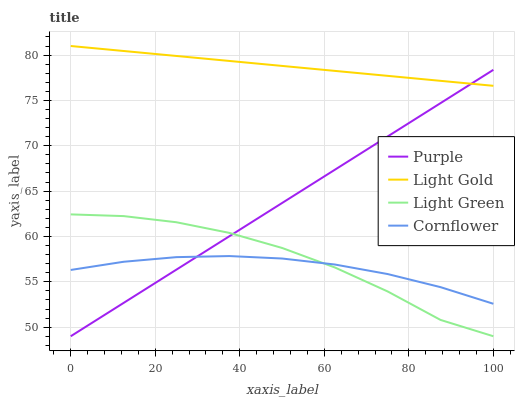Does Light Gold have the minimum area under the curve?
Answer yes or no. No. Does Cornflower have the maximum area under the curve?
Answer yes or no. No. Is Cornflower the smoothest?
Answer yes or no. No. Is Cornflower the roughest?
Answer yes or no. No. Does Cornflower have the lowest value?
Answer yes or no. No. Does Cornflower have the highest value?
Answer yes or no. No. Is Cornflower less than Light Gold?
Answer yes or no. Yes. Is Light Gold greater than Cornflower?
Answer yes or no. Yes. Does Cornflower intersect Light Gold?
Answer yes or no. No. 